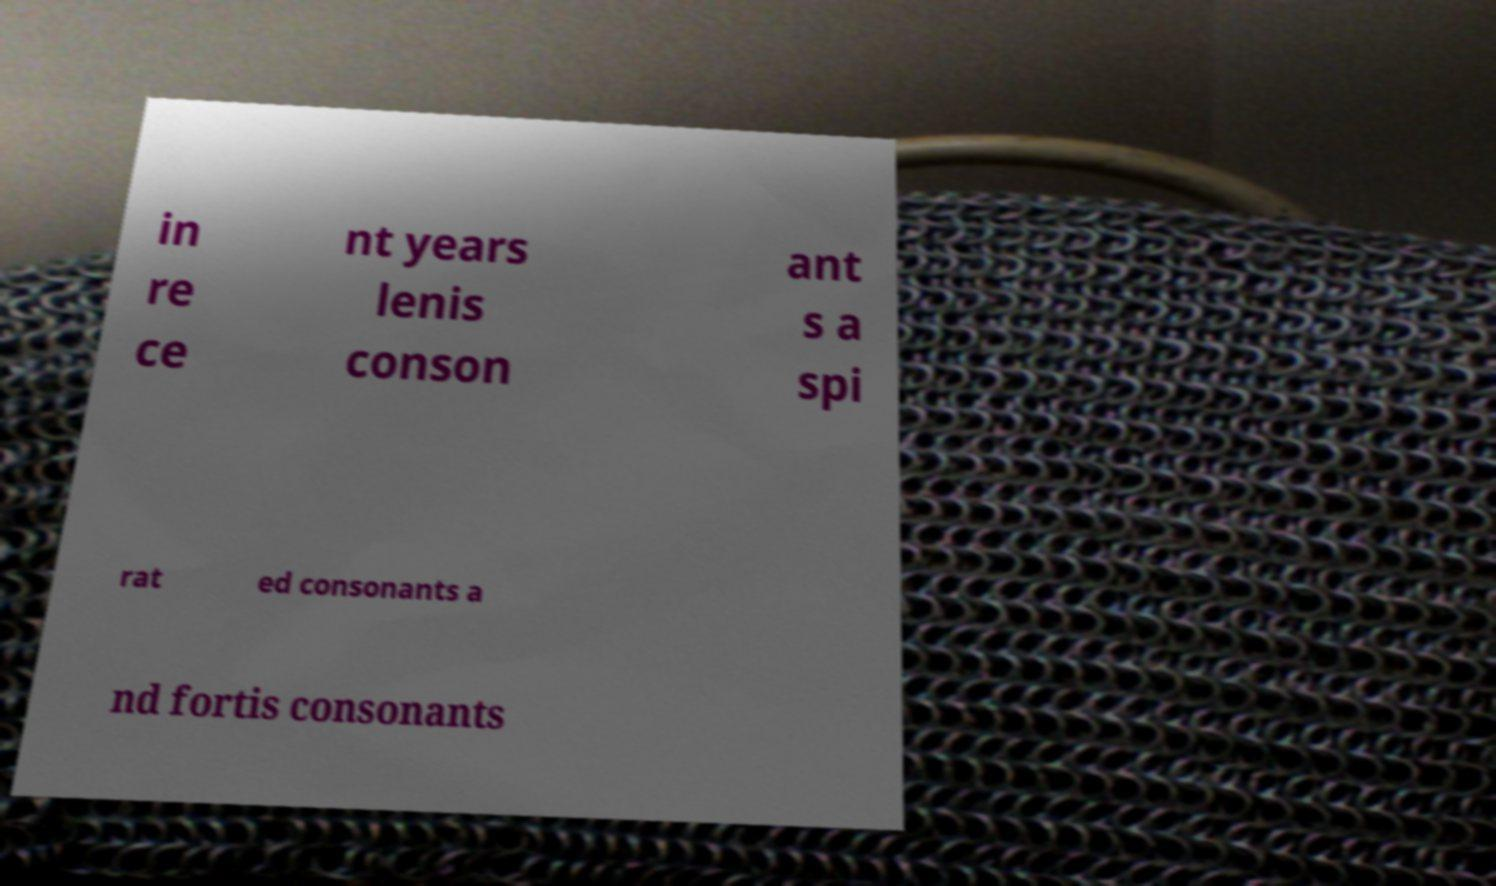I need the written content from this picture converted into text. Can you do that? in re ce nt years lenis conson ant s a spi rat ed consonants a nd fortis consonants 